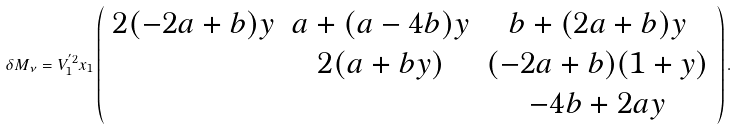Convert formula to latex. <formula><loc_0><loc_0><loc_500><loc_500>\delta M _ { \nu } = V _ { 1 } ^ { ^ { \prime } 2 } x _ { 1 } \left ( \begin{array} { c c c } 2 ( - 2 a + b ) y & a + ( a - 4 b ) y & b + ( 2 a + b ) y \\ & 2 ( a + b y ) & ( - 2 a + b ) ( 1 + y ) \\ & & - 4 b + 2 a y \end{array} \right ) .</formula> 